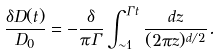<formula> <loc_0><loc_0><loc_500><loc_500>\frac { \delta D ( t ) } { D _ { 0 } } = - \frac { \delta } { \pi \Gamma } \int _ { \sim 1 } ^ { \Gamma t } \frac { d z } { ( 2 \pi z ) ^ { d / 2 } } .</formula> 